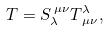Convert formula to latex. <formula><loc_0><loc_0><loc_500><loc_500>T = S _ { \lambda } ^ { \, \mu \nu } T ^ { \lambda } _ { \, \mu \nu } ,</formula> 